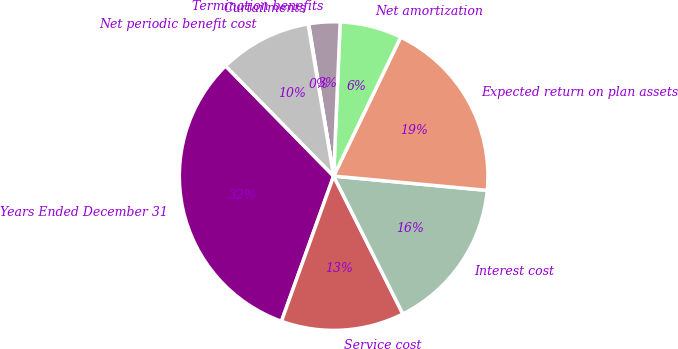<chart> <loc_0><loc_0><loc_500><loc_500><pie_chart><fcel>Years Ended December 31<fcel>Service cost<fcel>Interest cost<fcel>Expected return on plan assets<fcel>Net amortization<fcel>Termination benefits<fcel>Curtailments<fcel>Net periodic benefit cost<nl><fcel>32.16%<fcel>12.9%<fcel>16.11%<fcel>19.32%<fcel>6.48%<fcel>3.27%<fcel>0.06%<fcel>9.69%<nl></chart> 